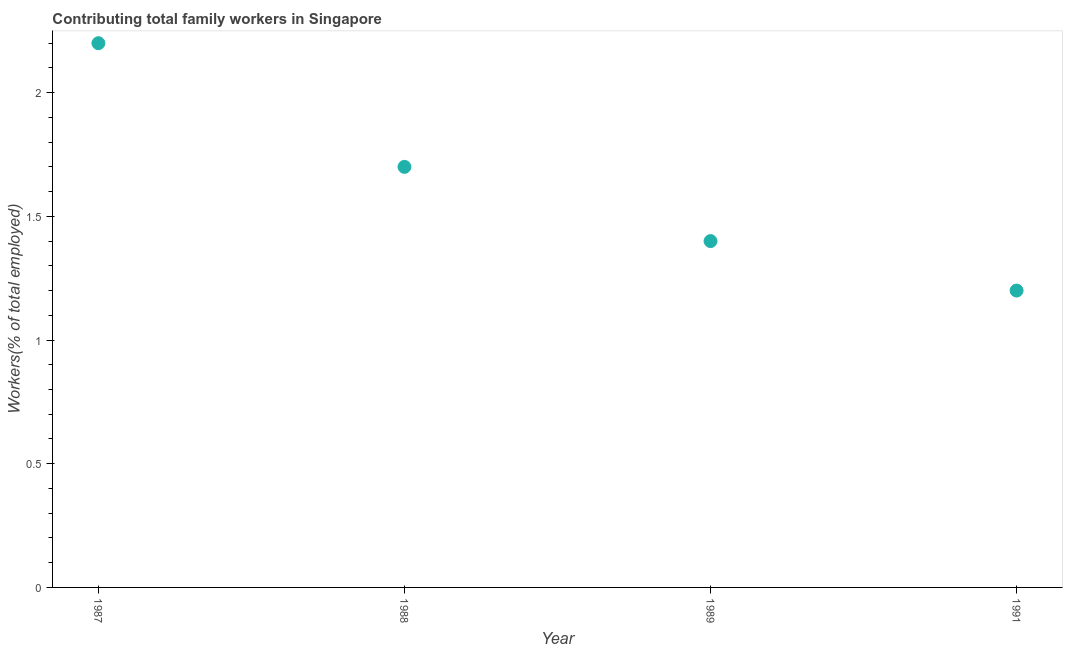What is the contributing family workers in 1988?
Your answer should be compact. 1.7. Across all years, what is the maximum contributing family workers?
Offer a terse response. 2.2. Across all years, what is the minimum contributing family workers?
Ensure brevity in your answer.  1.2. In which year was the contributing family workers maximum?
Provide a short and direct response. 1987. In which year was the contributing family workers minimum?
Ensure brevity in your answer.  1991. What is the sum of the contributing family workers?
Ensure brevity in your answer.  6.5. What is the difference between the contributing family workers in 1988 and 1991?
Give a very brief answer. 0.5. What is the average contributing family workers per year?
Provide a succinct answer. 1.63. What is the median contributing family workers?
Provide a short and direct response. 1.55. In how many years, is the contributing family workers greater than 1.2 %?
Your answer should be very brief. 4. What is the ratio of the contributing family workers in 1987 to that in 1988?
Ensure brevity in your answer.  1.29. Is the contributing family workers in 1987 less than that in 1989?
Offer a terse response. No. What is the difference between the highest and the second highest contributing family workers?
Offer a terse response. 0.5. Is the sum of the contributing family workers in 1987 and 1989 greater than the maximum contributing family workers across all years?
Offer a terse response. Yes. What is the difference between the highest and the lowest contributing family workers?
Offer a terse response. 1. In how many years, is the contributing family workers greater than the average contributing family workers taken over all years?
Keep it short and to the point. 2. Are the values on the major ticks of Y-axis written in scientific E-notation?
Your answer should be compact. No. Does the graph contain any zero values?
Your answer should be compact. No. What is the title of the graph?
Ensure brevity in your answer.  Contributing total family workers in Singapore. What is the label or title of the Y-axis?
Provide a succinct answer. Workers(% of total employed). What is the Workers(% of total employed) in 1987?
Give a very brief answer. 2.2. What is the Workers(% of total employed) in 1988?
Your response must be concise. 1.7. What is the Workers(% of total employed) in 1989?
Provide a succinct answer. 1.4. What is the Workers(% of total employed) in 1991?
Your answer should be compact. 1.2. What is the difference between the Workers(% of total employed) in 1987 and 1988?
Offer a terse response. 0.5. What is the difference between the Workers(% of total employed) in 1987 and 1991?
Provide a succinct answer. 1. What is the difference between the Workers(% of total employed) in 1988 and 1991?
Your answer should be compact. 0.5. What is the difference between the Workers(% of total employed) in 1989 and 1991?
Your answer should be very brief. 0.2. What is the ratio of the Workers(% of total employed) in 1987 to that in 1988?
Offer a terse response. 1.29. What is the ratio of the Workers(% of total employed) in 1987 to that in 1989?
Keep it short and to the point. 1.57. What is the ratio of the Workers(% of total employed) in 1987 to that in 1991?
Provide a succinct answer. 1.83. What is the ratio of the Workers(% of total employed) in 1988 to that in 1989?
Keep it short and to the point. 1.21. What is the ratio of the Workers(% of total employed) in 1988 to that in 1991?
Your answer should be compact. 1.42. What is the ratio of the Workers(% of total employed) in 1989 to that in 1991?
Your response must be concise. 1.17. 